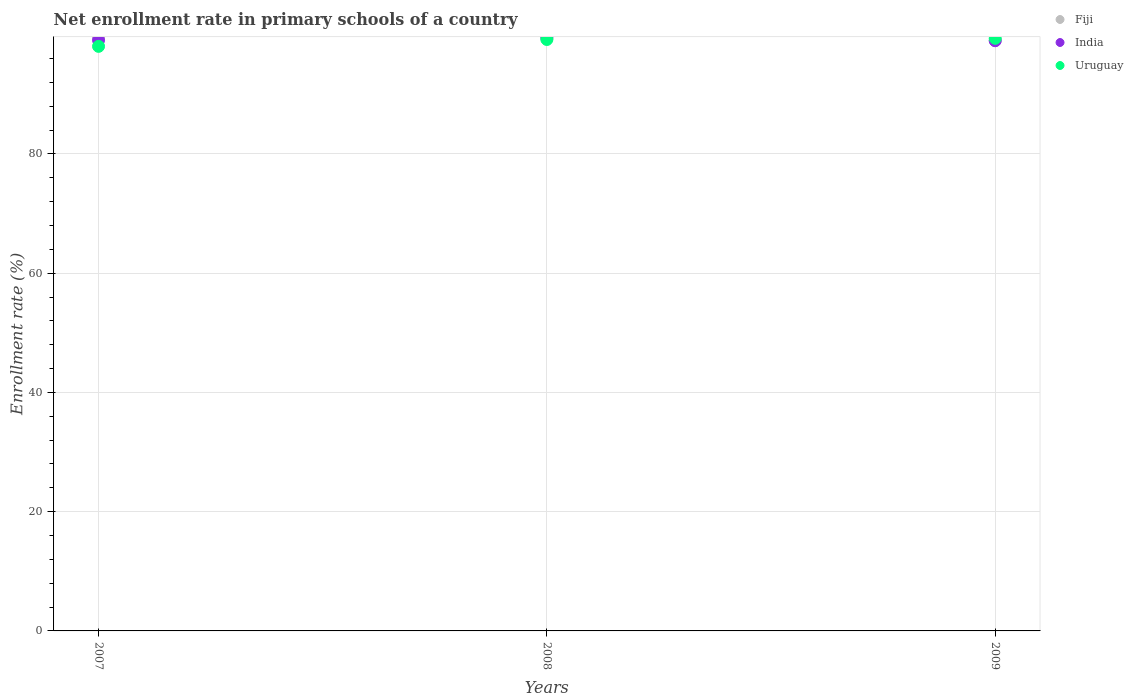Is the number of dotlines equal to the number of legend labels?
Make the answer very short. Yes. What is the enrollment rate in primary schools in Uruguay in 2007?
Provide a succinct answer. 98.06. Across all years, what is the maximum enrollment rate in primary schools in Uruguay?
Provide a succinct answer. 99.4. Across all years, what is the minimum enrollment rate in primary schools in Fiji?
Offer a very short reply. 99.04. In which year was the enrollment rate in primary schools in Uruguay maximum?
Keep it short and to the point. 2009. In which year was the enrollment rate in primary schools in Uruguay minimum?
Ensure brevity in your answer.  2007. What is the total enrollment rate in primary schools in India in the graph?
Ensure brevity in your answer.  297.67. What is the difference between the enrollment rate in primary schools in Uruguay in 2007 and that in 2008?
Keep it short and to the point. -1.15. What is the difference between the enrollment rate in primary schools in Fiji in 2008 and the enrollment rate in primary schools in India in 2007?
Make the answer very short. 0.24. What is the average enrollment rate in primary schools in Fiji per year?
Your answer should be compact. 99.33. In the year 2007, what is the difference between the enrollment rate in primary schools in India and enrollment rate in primary schools in Uruguay?
Give a very brief answer. 1.04. In how many years, is the enrollment rate in primary schools in India greater than 44 %?
Keep it short and to the point. 3. What is the ratio of the enrollment rate in primary schools in Uruguay in 2007 to that in 2008?
Your response must be concise. 0.99. Is the enrollment rate in primary schools in India in 2007 less than that in 2008?
Your answer should be compact. Yes. Is the difference between the enrollment rate in primary schools in India in 2007 and 2008 greater than the difference between the enrollment rate in primary schools in Uruguay in 2007 and 2008?
Your response must be concise. Yes. What is the difference between the highest and the second highest enrollment rate in primary schools in India?
Offer a very short reply. 0.49. What is the difference between the highest and the lowest enrollment rate in primary schools in India?
Provide a short and direct response. 0.58. Is it the case that in every year, the sum of the enrollment rate in primary schools in Fiji and enrollment rate in primary schools in Uruguay  is greater than the enrollment rate in primary schools in India?
Keep it short and to the point. Yes. Does the enrollment rate in primary schools in Uruguay monotonically increase over the years?
Keep it short and to the point. Yes. Are the values on the major ticks of Y-axis written in scientific E-notation?
Your answer should be compact. No. What is the title of the graph?
Make the answer very short. Net enrollment rate in primary schools of a country. What is the label or title of the X-axis?
Provide a short and direct response. Years. What is the label or title of the Y-axis?
Offer a very short reply. Enrollment rate (%). What is the Enrollment rate (%) in Fiji in 2007?
Your answer should be compact. 99.62. What is the Enrollment rate (%) of India in 2007?
Give a very brief answer. 99.09. What is the Enrollment rate (%) of Uruguay in 2007?
Provide a short and direct response. 98.06. What is the Enrollment rate (%) of Fiji in 2008?
Offer a terse response. 99.34. What is the Enrollment rate (%) in India in 2008?
Provide a succinct answer. 99.58. What is the Enrollment rate (%) in Uruguay in 2008?
Your answer should be very brief. 99.21. What is the Enrollment rate (%) of Fiji in 2009?
Your answer should be compact. 99.04. What is the Enrollment rate (%) in India in 2009?
Ensure brevity in your answer.  99. What is the Enrollment rate (%) in Uruguay in 2009?
Offer a very short reply. 99.4. Across all years, what is the maximum Enrollment rate (%) of Fiji?
Make the answer very short. 99.62. Across all years, what is the maximum Enrollment rate (%) of India?
Offer a very short reply. 99.58. Across all years, what is the maximum Enrollment rate (%) of Uruguay?
Give a very brief answer. 99.4. Across all years, what is the minimum Enrollment rate (%) in Fiji?
Your response must be concise. 99.04. Across all years, what is the minimum Enrollment rate (%) in India?
Make the answer very short. 99. Across all years, what is the minimum Enrollment rate (%) in Uruguay?
Offer a very short reply. 98.06. What is the total Enrollment rate (%) in Fiji in the graph?
Keep it short and to the point. 297.99. What is the total Enrollment rate (%) in India in the graph?
Your answer should be very brief. 297.67. What is the total Enrollment rate (%) in Uruguay in the graph?
Offer a very short reply. 296.66. What is the difference between the Enrollment rate (%) of Fiji in 2007 and that in 2008?
Keep it short and to the point. 0.28. What is the difference between the Enrollment rate (%) in India in 2007 and that in 2008?
Provide a short and direct response. -0.49. What is the difference between the Enrollment rate (%) in Uruguay in 2007 and that in 2008?
Offer a terse response. -1.15. What is the difference between the Enrollment rate (%) of Fiji in 2007 and that in 2009?
Keep it short and to the point. 0.58. What is the difference between the Enrollment rate (%) in India in 2007 and that in 2009?
Provide a succinct answer. 0.1. What is the difference between the Enrollment rate (%) in Uruguay in 2007 and that in 2009?
Make the answer very short. -1.34. What is the difference between the Enrollment rate (%) of Fiji in 2008 and that in 2009?
Offer a terse response. 0.3. What is the difference between the Enrollment rate (%) of India in 2008 and that in 2009?
Your answer should be compact. 0.58. What is the difference between the Enrollment rate (%) in Uruguay in 2008 and that in 2009?
Your answer should be very brief. -0.19. What is the difference between the Enrollment rate (%) of Fiji in 2007 and the Enrollment rate (%) of India in 2008?
Make the answer very short. 0.04. What is the difference between the Enrollment rate (%) of Fiji in 2007 and the Enrollment rate (%) of Uruguay in 2008?
Your answer should be very brief. 0.41. What is the difference between the Enrollment rate (%) in India in 2007 and the Enrollment rate (%) in Uruguay in 2008?
Make the answer very short. -0.11. What is the difference between the Enrollment rate (%) of Fiji in 2007 and the Enrollment rate (%) of India in 2009?
Offer a terse response. 0.62. What is the difference between the Enrollment rate (%) of Fiji in 2007 and the Enrollment rate (%) of Uruguay in 2009?
Your response must be concise. 0.22. What is the difference between the Enrollment rate (%) in India in 2007 and the Enrollment rate (%) in Uruguay in 2009?
Provide a succinct answer. -0.31. What is the difference between the Enrollment rate (%) in Fiji in 2008 and the Enrollment rate (%) in India in 2009?
Provide a short and direct response. 0.34. What is the difference between the Enrollment rate (%) in Fiji in 2008 and the Enrollment rate (%) in Uruguay in 2009?
Give a very brief answer. -0.06. What is the difference between the Enrollment rate (%) of India in 2008 and the Enrollment rate (%) of Uruguay in 2009?
Offer a terse response. 0.18. What is the average Enrollment rate (%) of Fiji per year?
Your answer should be very brief. 99.33. What is the average Enrollment rate (%) of India per year?
Offer a very short reply. 99.22. What is the average Enrollment rate (%) of Uruguay per year?
Provide a succinct answer. 98.89. In the year 2007, what is the difference between the Enrollment rate (%) of Fiji and Enrollment rate (%) of India?
Keep it short and to the point. 0.52. In the year 2007, what is the difference between the Enrollment rate (%) in Fiji and Enrollment rate (%) in Uruguay?
Ensure brevity in your answer.  1.56. In the year 2007, what is the difference between the Enrollment rate (%) of India and Enrollment rate (%) of Uruguay?
Keep it short and to the point. 1.04. In the year 2008, what is the difference between the Enrollment rate (%) of Fiji and Enrollment rate (%) of India?
Offer a terse response. -0.24. In the year 2008, what is the difference between the Enrollment rate (%) in Fiji and Enrollment rate (%) in Uruguay?
Offer a terse response. 0.13. In the year 2008, what is the difference between the Enrollment rate (%) of India and Enrollment rate (%) of Uruguay?
Keep it short and to the point. 0.37. In the year 2009, what is the difference between the Enrollment rate (%) in Fiji and Enrollment rate (%) in India?
Provide a succinct answer. 0.04. In the year 2009, what is the difference between the Enrollment rate (%) of Fiji and Enrollment rate (%) of Uruguay?
Provide a succinct answer. -0.36. In the year 2009, what is the difference between the Enrollment rate (%) in India and Enrollment rate (%) in Uruguay?
Your answer should be compact. -0.4. What is the ratio of the Enrollment rate (%) of Fiji in 2007 to that in 2008?
Give a very brief answer. 1. What is the ratio of the Enrollment rate (%) of Uruguay in 2007 to that in 2008?
Offer a terse response. 0.99. What is the ratio of the Enrollment rate (%) of Fiji in 2007 to that in 2009?
Keep it short and to the point. 1.01. What is the ratio of the Enrollment rate (%) in India in 2007 to that in 2009?
Keep it short and to the point. 1. What is the ratio of the Enrollment rate (%) of Uruguay in 2007 to that in 2009?
Offer a terse response. 0.99. What is the ratio of the Enrollment rate (%) of India in 2008 to that in 2009?
Ensure brevity in your answer.  1.01. What is the difference between the highest and the second highest Enrollment rate (%) of Fiji?
Offer a terse response. 0.28. What is the difference between the highest and the second highest Enrollment rate (%) in India?
Your response must be concise. 0.49. What is the difference between the highest and the second highest Enrollment rate (%) in Uruguay?
Offer a very short reply. 0.19. What is the difference between the highest and the lowest Enrollment rate (%) of Fiji?
Provide a short and direct response. 0.58. What is the difference between the highest and the lowest Enrollment rate (%) of India?
Give a very brief answer. 0.58. What is the difference between the highest and the lowest Enrollment rate (%) in Uruguay?
Provide a short and direct response. 1.34. 